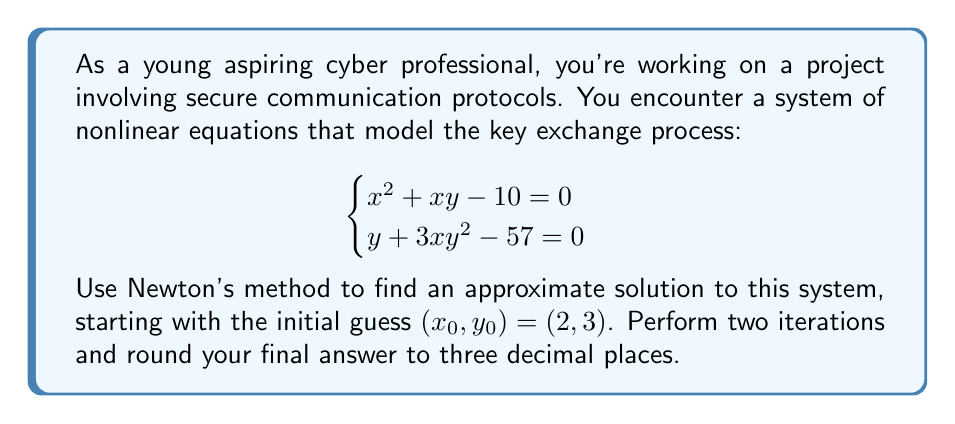Can you solve this math problem? Let's solve this system using Newton's method:

1) First, define our functions:
   $f_1(x,y) = x^2 + xy - 10$
   $f_2(x,y) = y + 3xy^2 - 57$

2) Calculate the Jacobian matrix:
   $$J = \begin{bmatrix}
   \frac{\partial f_1}{\partial x} & \frac{\partial f_1}{\partial y} \\
   \frac{\partial f_2}{\partial x} & \frac{\partial f_2}{\partial y}
   \end{bmatrix} = \begin{bmatrix}
   2x + y & x \\
   3y^2 & 1 + 6xy
   \end{bmatrix}$$

3) Newton's method iteration:
   $$(x_{n+1}, y_{n+1}) = (x_n, y_n) - J^{-1}(x_n, y_n) \cdot F(x_n, y_n)$$

   where $F(x,y) = \begin{bmatrix} f_1(x,y) \\ f_2(x,y) \end{bmatrix}$

4) First iteration $(n=0)$:
   At $(x_0, y_0) = (2, 3)$:
   
   $J(2,3) = \begin{bmatrix} 7 & 2 \\ 27 & 37 \end{bmatrix}$
   
   $F(2,3) = \begin{bmatrix} 2^2 + 2\cdot3 - 10 \\ 3 + 3\cdot2\cdot3^2 - 57 \end{bmatrix} = \begin{bmatrix} 0 \\ -0 \end{bmatrix}$
   
   $J^{-1}(2,3) = \frac{1}{259-54}\begin{bmatrix} 37 & -2 \\ -27 & 7 \end{bmatrix} = \begin{bmatrix} 0.1805 & -0.0098 \\ -0.1317 & 0.0341 \end{bmatrix}$
   
   $(x_1, y_1) = (2, 3) - \begin{bmatrix} 0.1805 & -0.0098 \\ -0.1317 & 0.0341 \end{bmatrix} \cdot \begin{bmatrix} 0 \\ -0 \end{bmatrix} = (2, 3)$

5) Second iteration $(n=1)$:
   Since $(x_1, y_1) = (x_0, y_0)$, the second iteration will yield the same result.

Therefore, after two iterations, we get $(x_2, y_2) = (2, 3)$.
Answer: $(2.000, 3.000)$ 